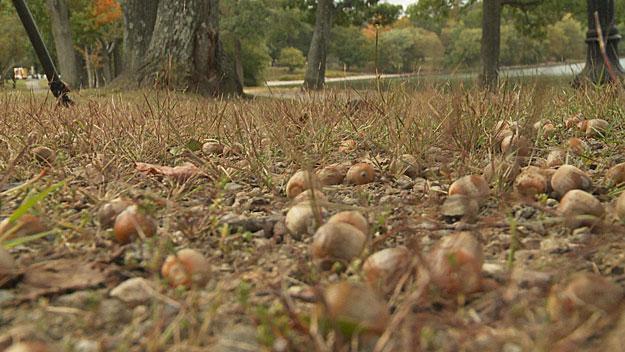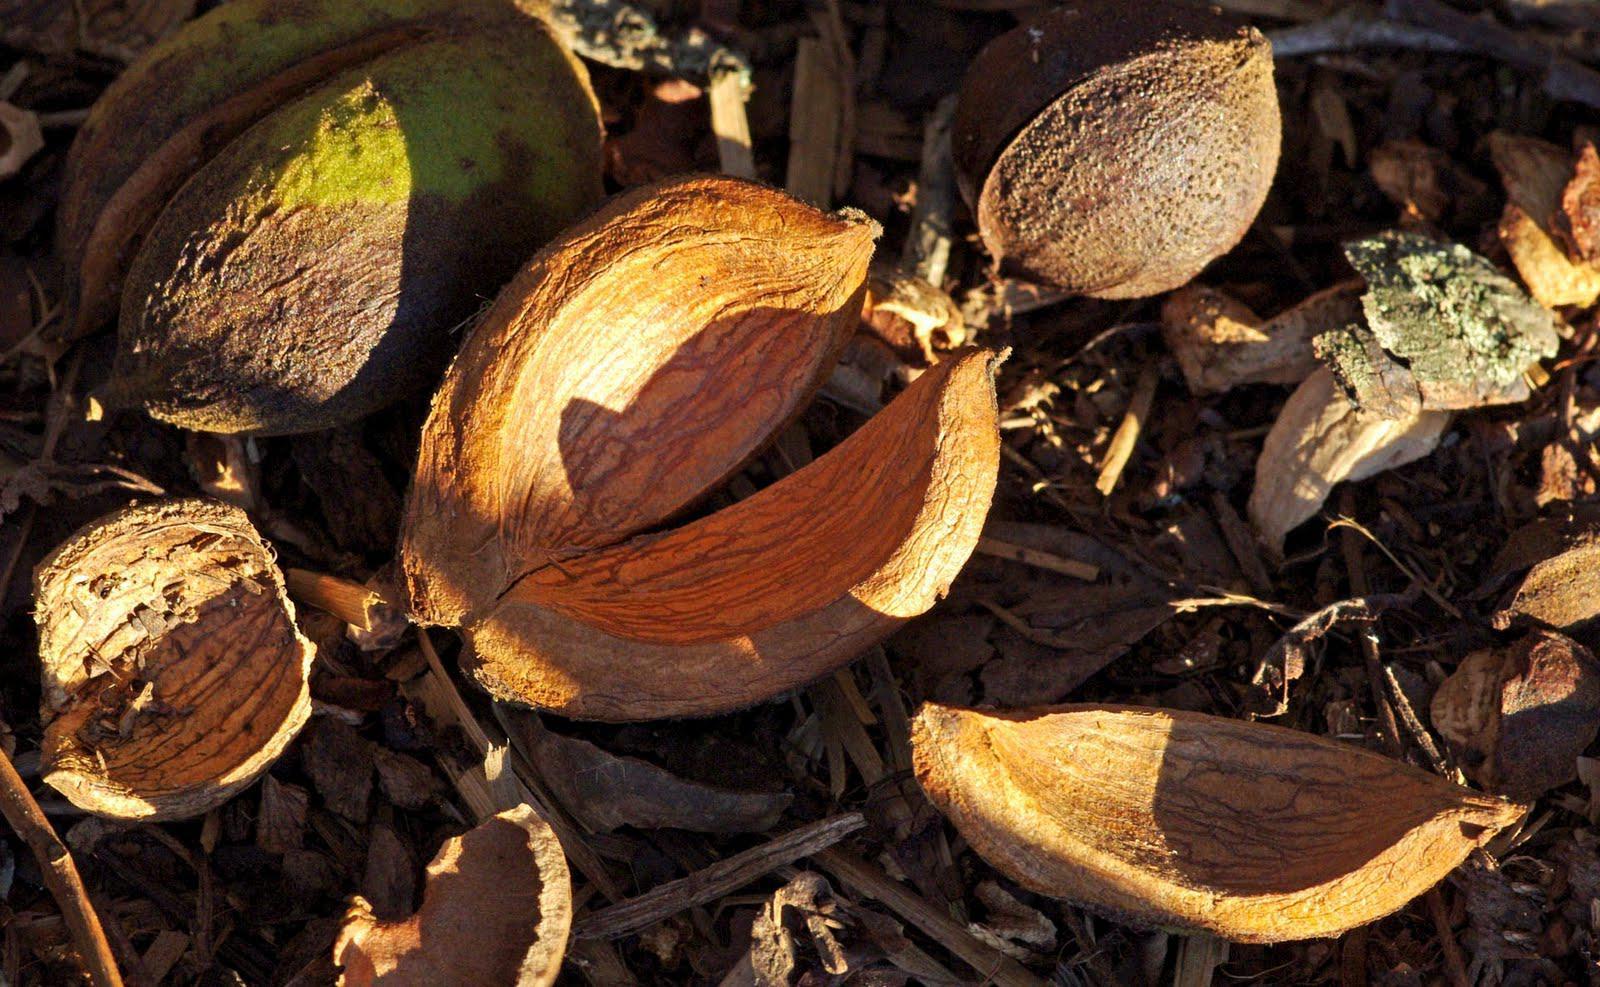The first image is the image on the left, the second image is the image on the right. Considering the images on both sides, is "In at least one  image there is a cracked acorn sitting on dirt and leaves on the ground." valid? Answer yes or no. Yes. The first image is the image on the left, the second image is the image on the right. Assess this claim about the two images: "The acorns are lying on the ground.". Correct or not? Answer yes or no. Yes. 